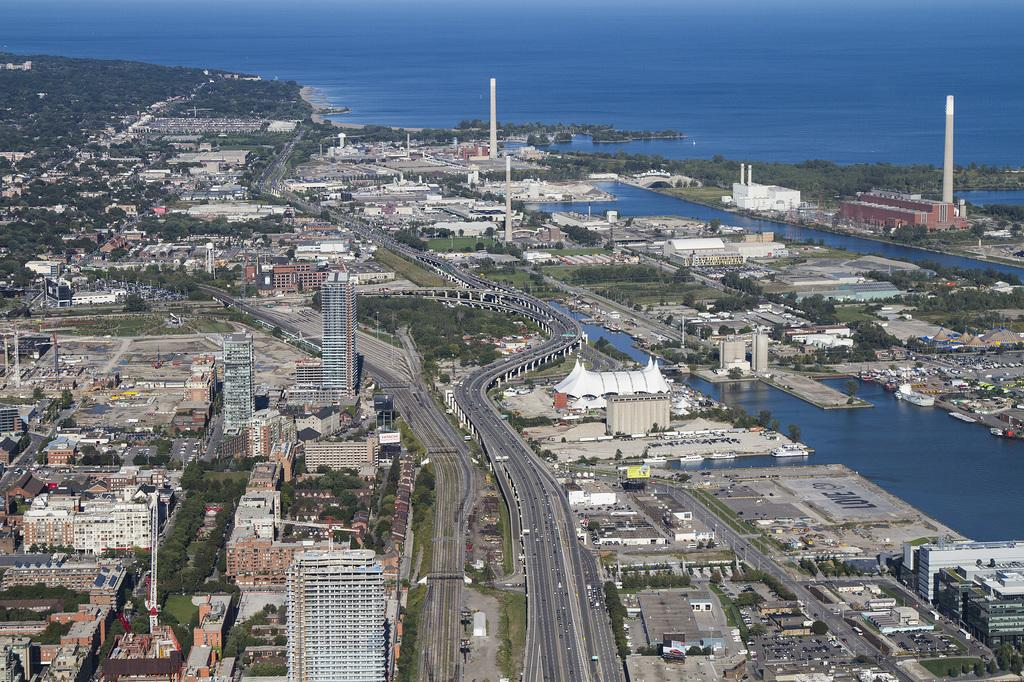What type of structures can be seen in the image? There are buildings and towers in the image. What natural elements are present in the image? There are trees and water visible in the image. What type of transportation is depicted in the image? There are vehicles in the image. What is the primary mode of transportation shown in the image? The primary mode of transportation is likely the road, as it is visible in the image. How many chairs are placed near the water in the image? There are no chairs present in the image. What is the value of the ocean in the image? There is no ocean present in the image, so it is not possible to determine its value. 